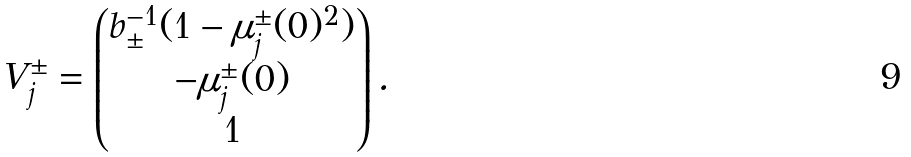Convert formula to latex. <formula><loc_0><loc_0><loc_500><loc_500>V _ { j } ^ { \pm } = \begin{pmatrix} b _ { \pm } ^ { - 1 } ( 1 - \mu _ { j } ^ { \pm } ( 0 ) ^ { 2 } ) \\ - \mu _ { j } ^ { \pm } ( 0 ) \\ 1 \end{pmatrix} .</formula> 